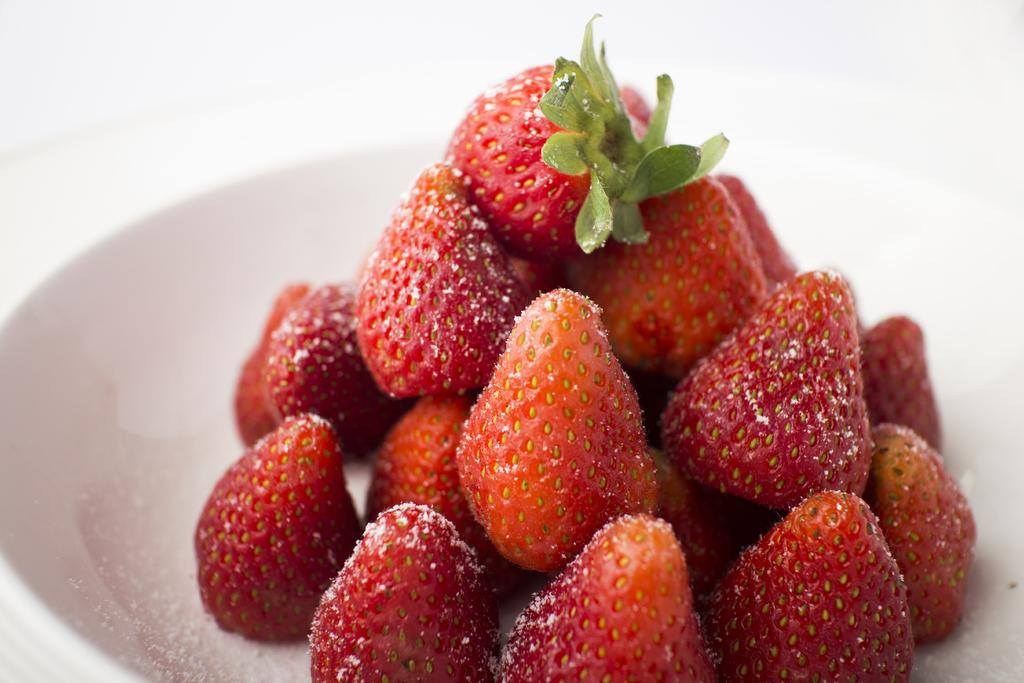What is in the bowl that is visible in the image? There is a bowl in the image, and it contains strawberries. What type of note can be seen attached to the wing of the strawberry in the image? There is no note or wing present in the image; it features a bowl of strawberries. 